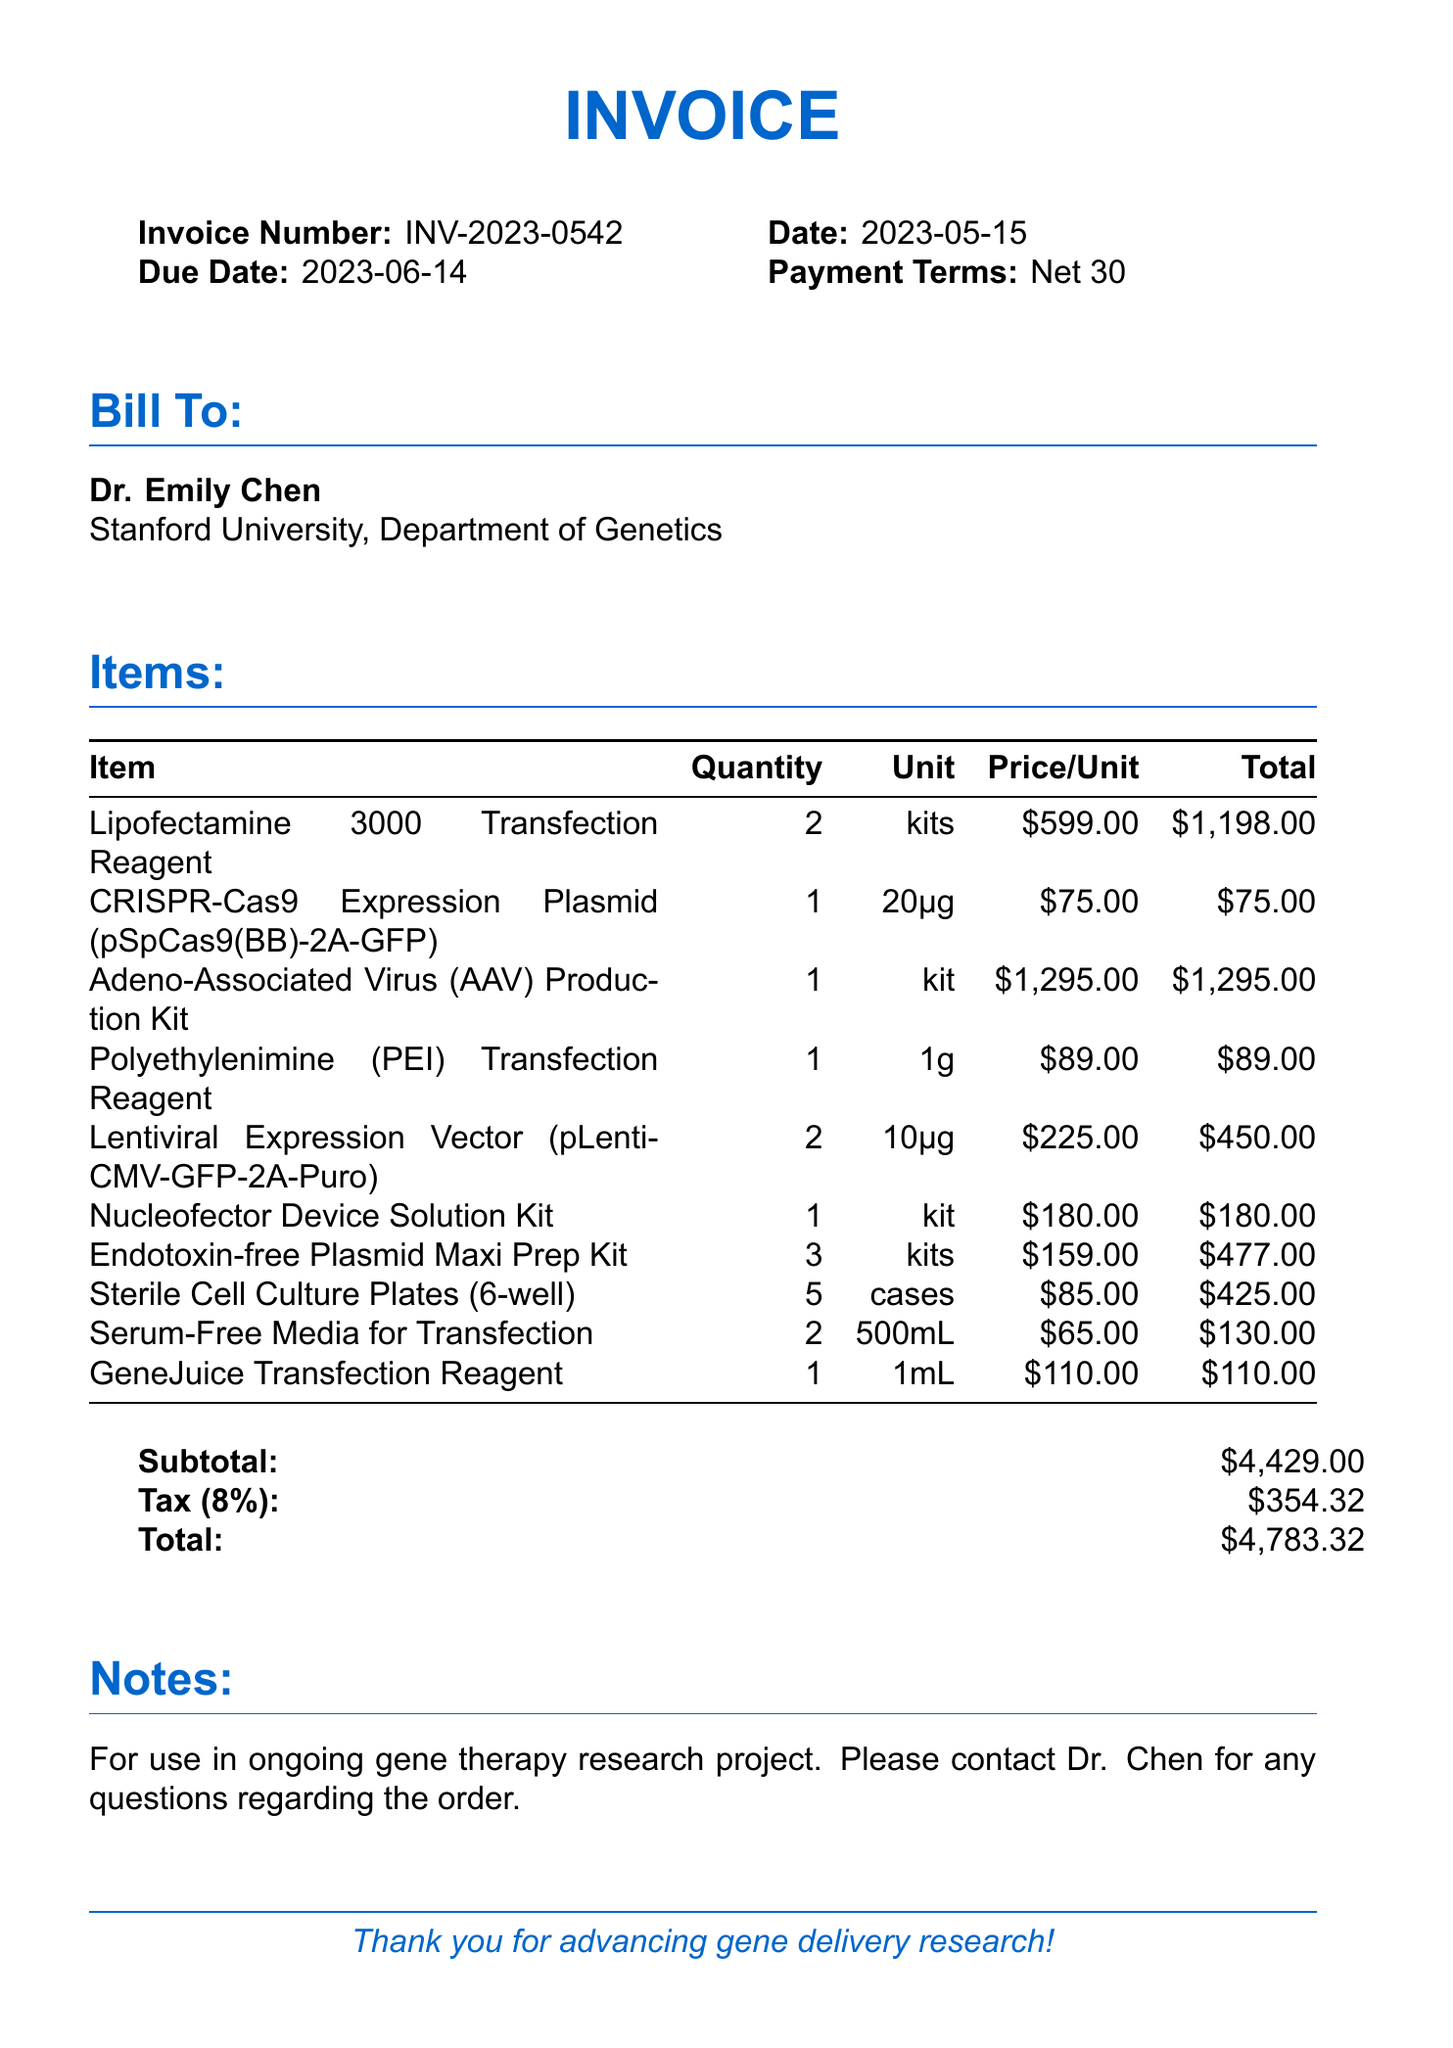What is the invoice number? The invoice number is provided at the top of the invoice for identification.
Answer: INV-2023-0542 Who is the invoice billed to? The invoice specifies the name of the researcher or entity the bill is directed to.
Answer: Dr. Emily Chen How many kits of Lipofectamine 3000 Transfection Reagent were ordered? The quantity of each item is listed in the items section of the invoice.
Answer: 2 What is the subtotal of the invoice? The subtotal is a sum of all item totals before tax is applied.
Answer: $4429.00 What is the tax rate applied to this invoice? The tax rate can be found in the summary section of the invoice.
Answer: 8% What is the total amount due? The total amount is the final figure after the subtotal and tax have been calculated.
Answer: $4783.32 Which reagent is available in 1g quantity? The items listed include specific products with their respective quantities.
Answer: Polyethylenimine (PEI) Transfection Reagent What are the payment terms listed in the invoice? Payment terms define the timeline for payment which is included in the document.
Answer: Net 30 How many cases of Sterile Cell Culture Plates were purchased? The quantity of each item ordered is distinctly mentioned next to each product.
Answer: 5 